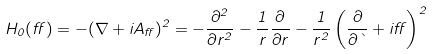<formula> <loc_0><loc_0><loc_500><loc_500>H _ { 0 } ( \alpha ) = - ( \nabla + i A _ { \alpha } ) ^ { 2 } = - \frac { \partial ^ { 2 } } { \partial r ^ { 2 } } - \frac { 1 } { r } \frac { \partial } { \partial r } - \frac { 1 } { r ^ { 2 } } \left ( \frac { \partial } { \partial \theta } + i \alpha \right ) ^ { 2 }</formula> 